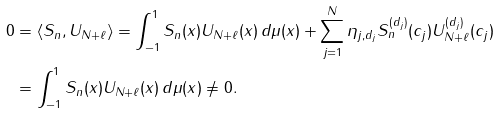Convert formula to latex. <formula><loc_0><loc_0><loc_500><loc_500>0 & = \langle S _ { n } , U _ { N + \ell } \rangle = \int _ { - 1 } ^ { 1 } S _ { n } ( x ) U _ { N + \ell } ( x ) \, d \mu ( x ) + \sum _ { j = 1 } ^ { N } \eta _ { j , d _ { j } } S _ { n } ^ { ( d _ { j } ) } ( c _ { j } ) U _ { N + \ell } ^ { ( d _ { j } ) } ( c _ { j } ) \\ & = \int _ { - 1 } ^ { 1 } S _ { n } ( x ) U _ { N + \ell } ( x ) \, d \mu ( x ) \neq 0 .</formula> 